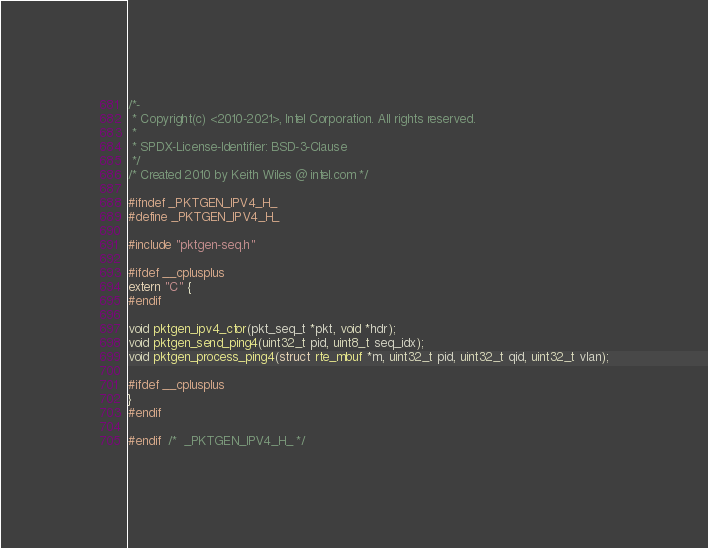<code> <loc_0><loc_0><loc_500><loc_500><_C_>/*-
 * Copyright(c) <2010-2021>, Intel Corporation. All rights reserved.
 *
 * SPDX-License-Identifier: BSD-3-Clause
 */
/* Created 2010 by Keith Wiles @ intel.com */

#ifndef _PKTGEN_IPV4_H_
#define _PKTGEN_IPV4_H_

#include "pktgen-seq.h"

#ifdef __cplusplus
extern "C" {
#endif

void pktgen_ipv4_ctor(pkt_seq_t *pkt, void *hdr);
void pktgen_send_ping4(uint32_t pid, uint8_t seq_idx);
void pktgen_process_ping4(struct rte_mbuf *m, uint32_t pid, uint32_t qid, uint32_t vlan);

#ifdef __cplusplus
}
#endif

#endif  /*  _PKTGEN_IPV4_H_ */
</code> 